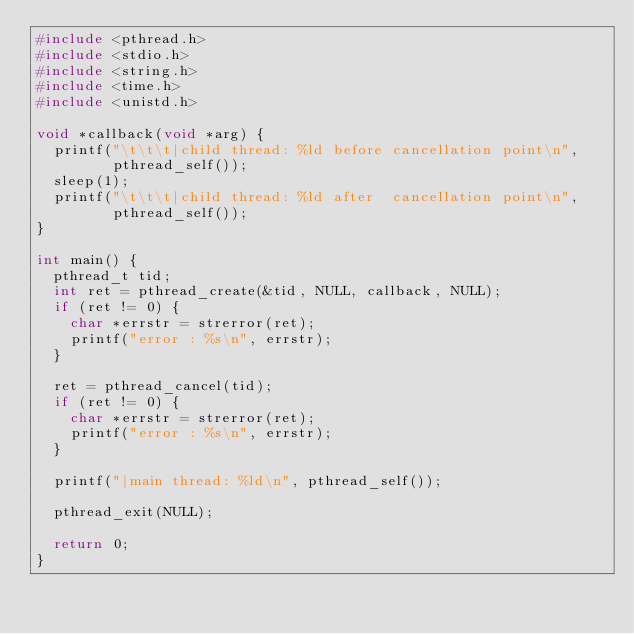Convert code to text. <code><loc_0><loc_0><loc_500><loc_500><_C_>#include <pthread.h>
#include <stdio.h>
#include <string.h>
#include <time.h>
#include <unistd.h>

void *callback(void *arg) {
  printf("\t\t\t|child thread: %ld before cancellation point\n",
         pthread_self());
  sleep(1);
  printf("\t\t\t|child thread: %ld after  cancellation point\n",
         pthread_self());
}

int main() {
  pthread_t tid;
  int ret = pthread_create(&tid, NULL, callback, NULL);
  if (ret != 0) {
    char *errstr = strerror(ret);
    printf("error : %s\n", errstr);
  }

  ret = pthread_cancel(tid);
  if (ret != 0) {
    char *errstr = strerror(ret);
    printf("error : %s\n", errstr);
  }

  printf("|main thread: %ld\n", pthread_self());

  pthread_exit(NULL);

  return 0;
}
</code> 